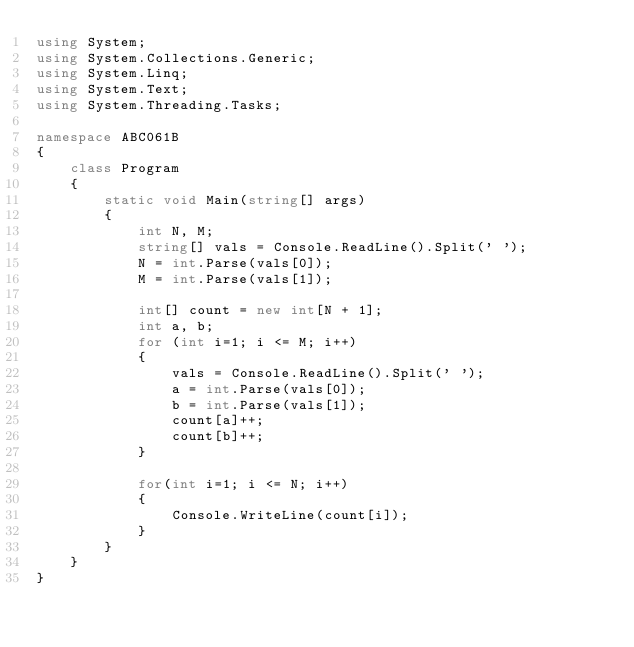<code> <loc_0><loc_0><loc_500><loc_500><_C#_>using System;
using System.Collections.Generic;
using System.Linq;
using System.Text;
using System.Threading.Tasks;

namespace ABC061B
{
    class Program
    {
        static void Main(string[] args)
        {
            int N, M;
            string[] vals = Console.ReadLine().Split(' ');
            N = int.Parse(vals[0]);
            M = int.Parse(vals[1]);

            int[] count = new int[N + 1];
            int a, b;
            for (int i=1; i <= M; i++)
            {
                vals = Console.ReadLine().Split(' ');
                a = int.Parse(vals[0]);
                b = int.Parse(vals[1]);
                count[a]++;
                count[b]++;
            }

            for(int i=1; i <= N; i++)
            {
                Console.WriteLine(count[i]);
            }
        }
    }
}
</code> 